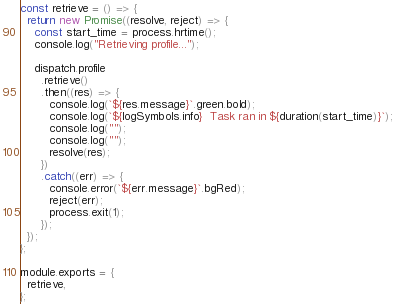<code> <loc_0><loc_0><loc_500><loc_500><_JavaScript_>const retrieve = () => {
  return new Promise((resolve, reject) => {
    const start_time = process.hrtime();
    console.log("Retrieving profile...");

    dispatch.profile
      .retrieve()
      .then((res) => {
        console.log(`${res.message}`.green.bold);
        console.log(`${logSymbols.info}  Task ran in ${duration(start_time)}`);
        console.log("");
        console.log("");
        resolve(res);
      })
      .catch((err) => {
        console.error(`${err.message}`.bgRed);
        reject(err);
        process.exit(1);
      });
  });
};

module.exports = {
  retrieve,
};
</code> 